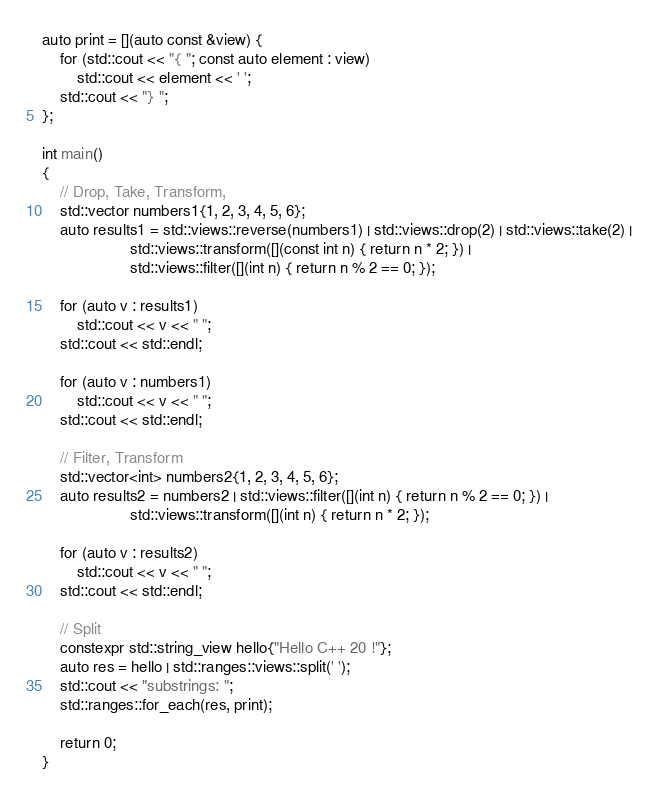<code> <loc_0><loc_0><loc_500><loc_500><_C++_>auto print = [](auto const &view) {
    for (std::cout << "{ "; const auto element : view)
        std::cout << element << ' ';
    std::cout << "} ";
};

int main()
{
    // Drop, Take, Transform,
    std::vector numbers1{1, 2, 3, 4, 5, 6};
    auto results1 = std::views::reverse(numbers1) | std::views::drop(2) | std::views::take(2) |
                    std::views::transform([](const int n) { return n * 2; }) |
                    std::views::filter([](int n) { return n % 2 == 0; });

    for (auto v : results1)
        std::cout << v << " ";
    std::cout << std::endl;

    for (auto v : numbers1)
        std::cout << v << " ";
    std::cout << std::endl;

    // Filter, Transform
    std::vector<int> numbers2{1, 2, 3, 4, 5, 6};
    auto results2 = numbers2 | std::views::filter([](int n) { return n % 2 == 0; }) |
                    std::views::transform([](int n) { return n * 2; });

    for (auto v : results2)
        std::cout << v << " ";
    std::cout << std::endl;

    // Split
    constexpr std::string_view hello{"Hello C++ 20 !"};
    auto res = hello | std::ranges::views::split(' ');
    std::cout << "substrings: ";
    std::ranges::for_each(res, print);

    return 0;
}
</code> 